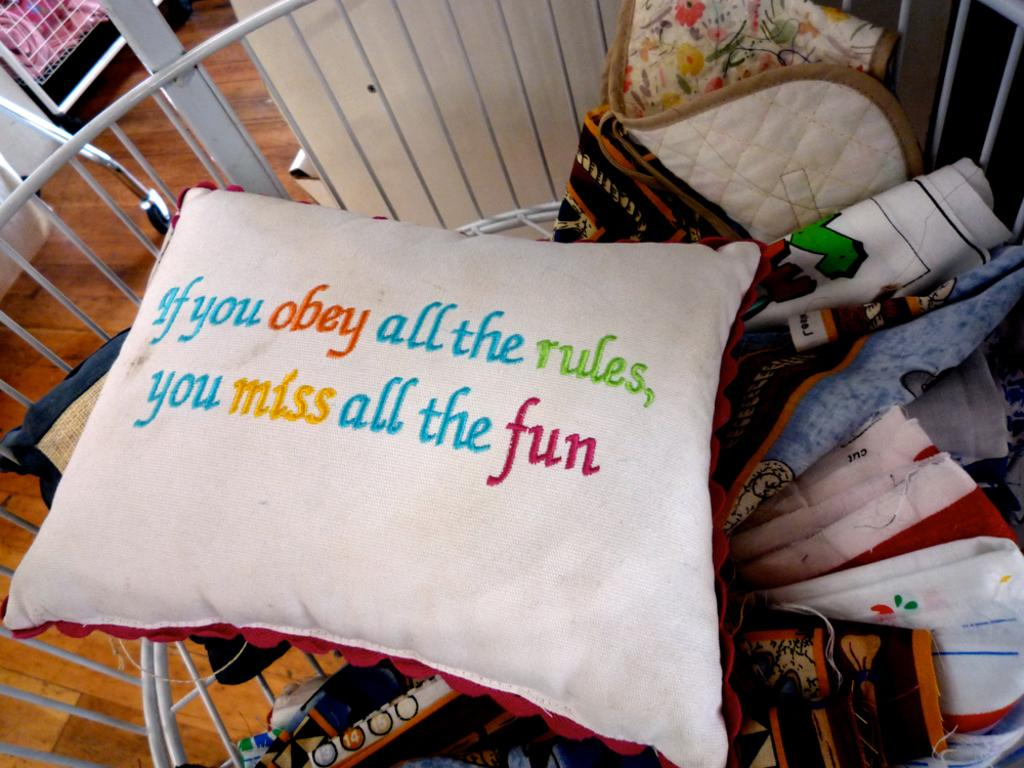What type of object can be seen in the image? There is a pillow in the image. What is the white object in the image used for? The white object is used for storing clothes. What material is the surface on which the pillow is placed? The surface is made of wood. Can you describe the objects on the left side of the image? Unfortunately, the provided facts do not specify the objects on the left side of the image. What type of land can be seen in the image? There is no land visible in the image; it only shows a pillow, a white object for storing clothes, and a wooden surface. How many apples are present in the image? There are no apples present in the image. 